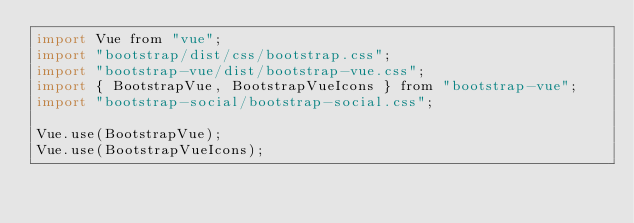<code> <loc_0><loc_0><loc_500><loc_500><_JavaScript_>import Vue from "vue";
import "bootstrap/dist/css/bootstrap.css";
import "bootstrap-vue/dist/bootstrap-vue.css";
import { BootstrapVue, BootstrapVueIcons } from "bootstrap-vue";
import "bootstrap-social/bootstrap-social.css";

Vue.use(BootstrapVue);
Vue.use(BootstrapVueIcons);
</code> 